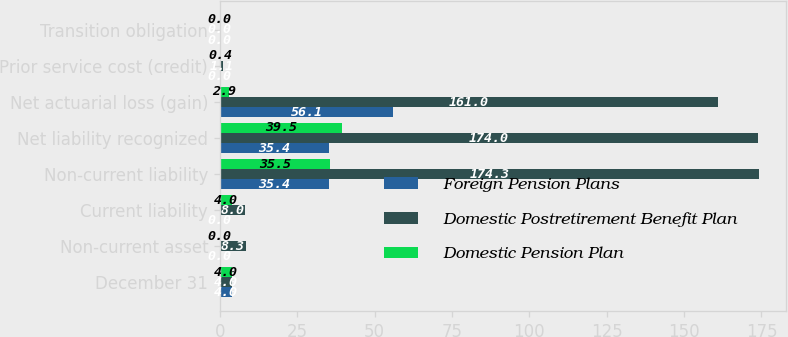Convert chart to OTSL. <chart><loc_0><loc_0><loc_500><loc_500><stacked_bar_chart><ecel><fcel>December 31<fcel>Non-current asset<fcel>Current liability<fcel>Non-current liability<fcel>Net liability recognized<fcel>Net actuarial loss (gain)<fcel>Prior service cost (credit)<fcel>Transition obligation<nl><fcel>Foreign Pension Plans<fcel>4<fcel>0<fcel>0<fcel>35.4<fcel>35.4<fcel>56.1<fcel>0<fcel>0<nl><fcel>Domestic Postretirement Benefit Plan<fcel>4<fcel>8.3<fcel>8<fcel>174.3<fcel>174<fcel>161<fcel>1.1<fcel>0<nl><fcel>Domestic Pension Plan<fcel>4<fcel>0<fcel>4<fcel>35.5<fcel>39.5<fcel>2.9<fcel>0.4<fcel>0<nl></chart> 